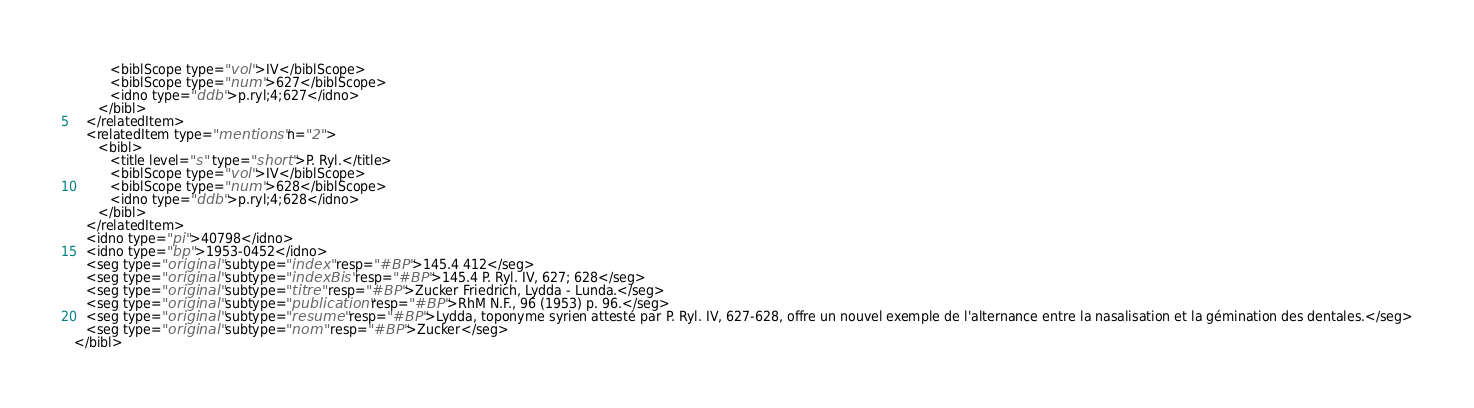Convert code to text. <code><loc_0><loc_0><loc_500><loc_500><_XML_>         <biblScope type="vol">IV</biblScope>
         <biblScope type="num">627</biblScope>
         <idno type="ddb">p.ryl;4;627</idno>
      </bibl>
   </relatedItem>
   <relatedItem type="mentions" n="2">
      <bibl>
         <title level="s" type="short">P. Ryl.</title>
         <biblScope type="vol">IV</biblScope>
         <biblScope type="num">628</biblScope>
         <idno type="ddb">p.ryl;4;628</idno>
      </bibl>
   </relatedItem>
   <idno type="pi">40798</idno>
   <idno type="bp">1953-0452</idno>
   <seg type="original" subtype="index" resp="#BP">145.4 412</seg>
   <seg type="original" subtype="indexBis" resp="#BP">145.4 P. Ryl. IV, 627; 628</seg>
   <seg type="original" subtype="titre" resp="#BP">Zucker Friedrich, Lydda - Lunda.</seg>
   <seg type="original" subtype="publication" resp="#BP">RhM N.F., 96 (1953) p. 96.</seg>
   <seg type="original" subtype="resume" resp="#BP">Lydda, toponyme syrien attesté par P. Ryl. IV, 627-628, offre un nouvel exemple de l'alternance entre la nasalisation et la gémination des dentales.</seg>
   <seg type="original" subtype="nom" resp="#BP">Zucker</seg>
</bibl>
</code> 